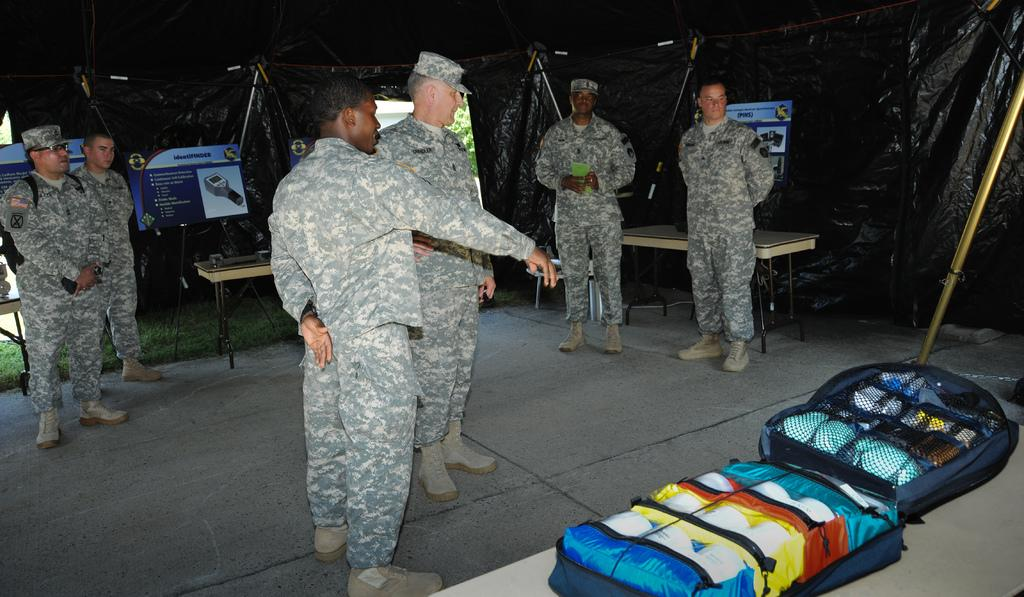What is the main subject in the center of the image? There are army men in the center of the image. Are there any other army men visible in the image? Yes, there are army men on the left side of the image. Where are the army men located in the image? The army men are inside a tent. What can be seen in the bottom right side of the image? There are bags in the bottom right side of the image. What type of sweater is the army man wearing in the image? There is no sweater mentioned or visible in the image; the army men are not wearing any clothing. 